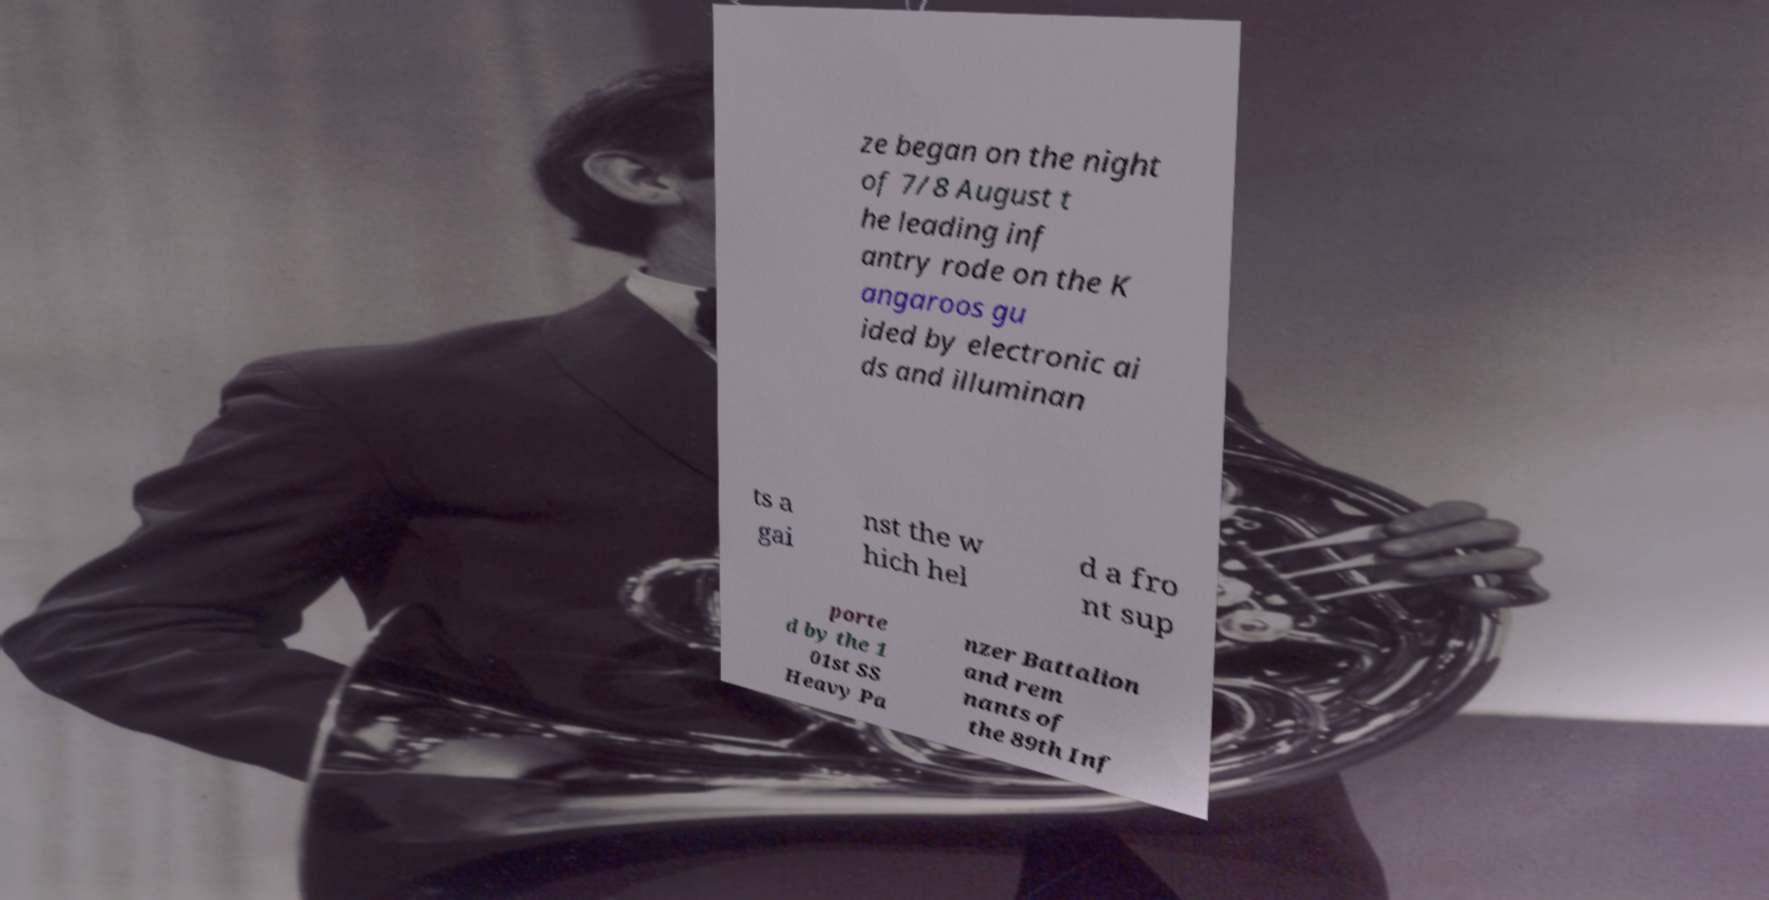What messages or text are displayed in this image? I need them in a readable, typed format. ze began on the night of 7/8 August t he leading inf antry rode on the K angaroos gu ided by electronic ai ds and illuminan ts a gai nst the w hich hel d a fro nt sup porte d by the 1 01st SS Heavy Pa nzer Battalion and rem nants of the 89th Inf 